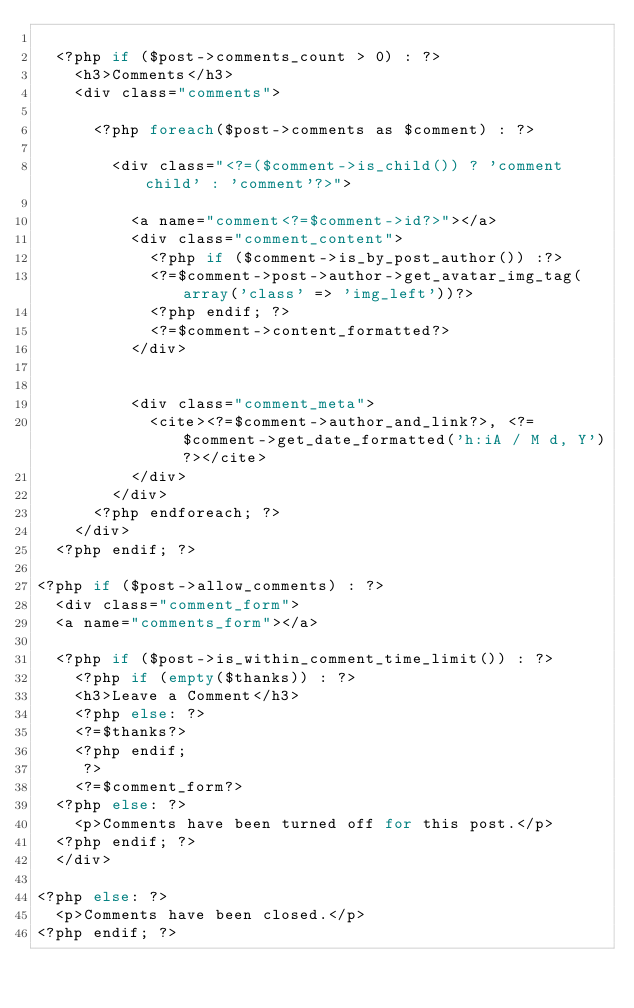<code> <loc_0><loc_0><loc_500><loc_500><_PHP_>
	<?php if ($post->comments_count > 0) : ?>
		<h3>Comments</h3>
		<div class="comments">

			<?php foreach($post->comments as $comment) : ?>

				<div class="<?=($comment->is_child()) ? 'comment child' : 'comment'?>">

					<a name="comment<?=$comment->id?>"></a>
					<div class="comment_content">
						<?php if ($comment->is_by_post_author()) :?>
						<?=$comment->post->author->get_avatar_img_tag(array('class' => 'img_left'))?>
						<?php endif; ?>
						<?=$comment->content_formatted?>
					</div>


					<div class="comment_meta">
						<cite><?=$comment->author_and_link?>, <?=$comment->get_date_formatted('h:iA / M d, Y')?></cite>
					</div>
				</div>
			<?php endforeach; ?>
		</div>
	<?php endif; ?>

<?php if ($post->allow_comments) : ?>
	<div class="comment_form">
	<a name="comments_form"></a>

	<?php if ($post->is_within_comment_time_limit()) : ?>
		<?php if (empty($thanks)) : ?>
		<h3>Leave a Comment</h3>
		<?php else: ?>
		<?=$thanks?>
		<?php endif;
		 ?>
		<?=$comment_form?>
	<?php else: ?>
		<p>Comments have been turned off for this post.</p>
	<?php endif; ?>
	</div>

<?php else: ?>
	<p>Comments have been closed.</p>
<?php endif; ?>
</code> 